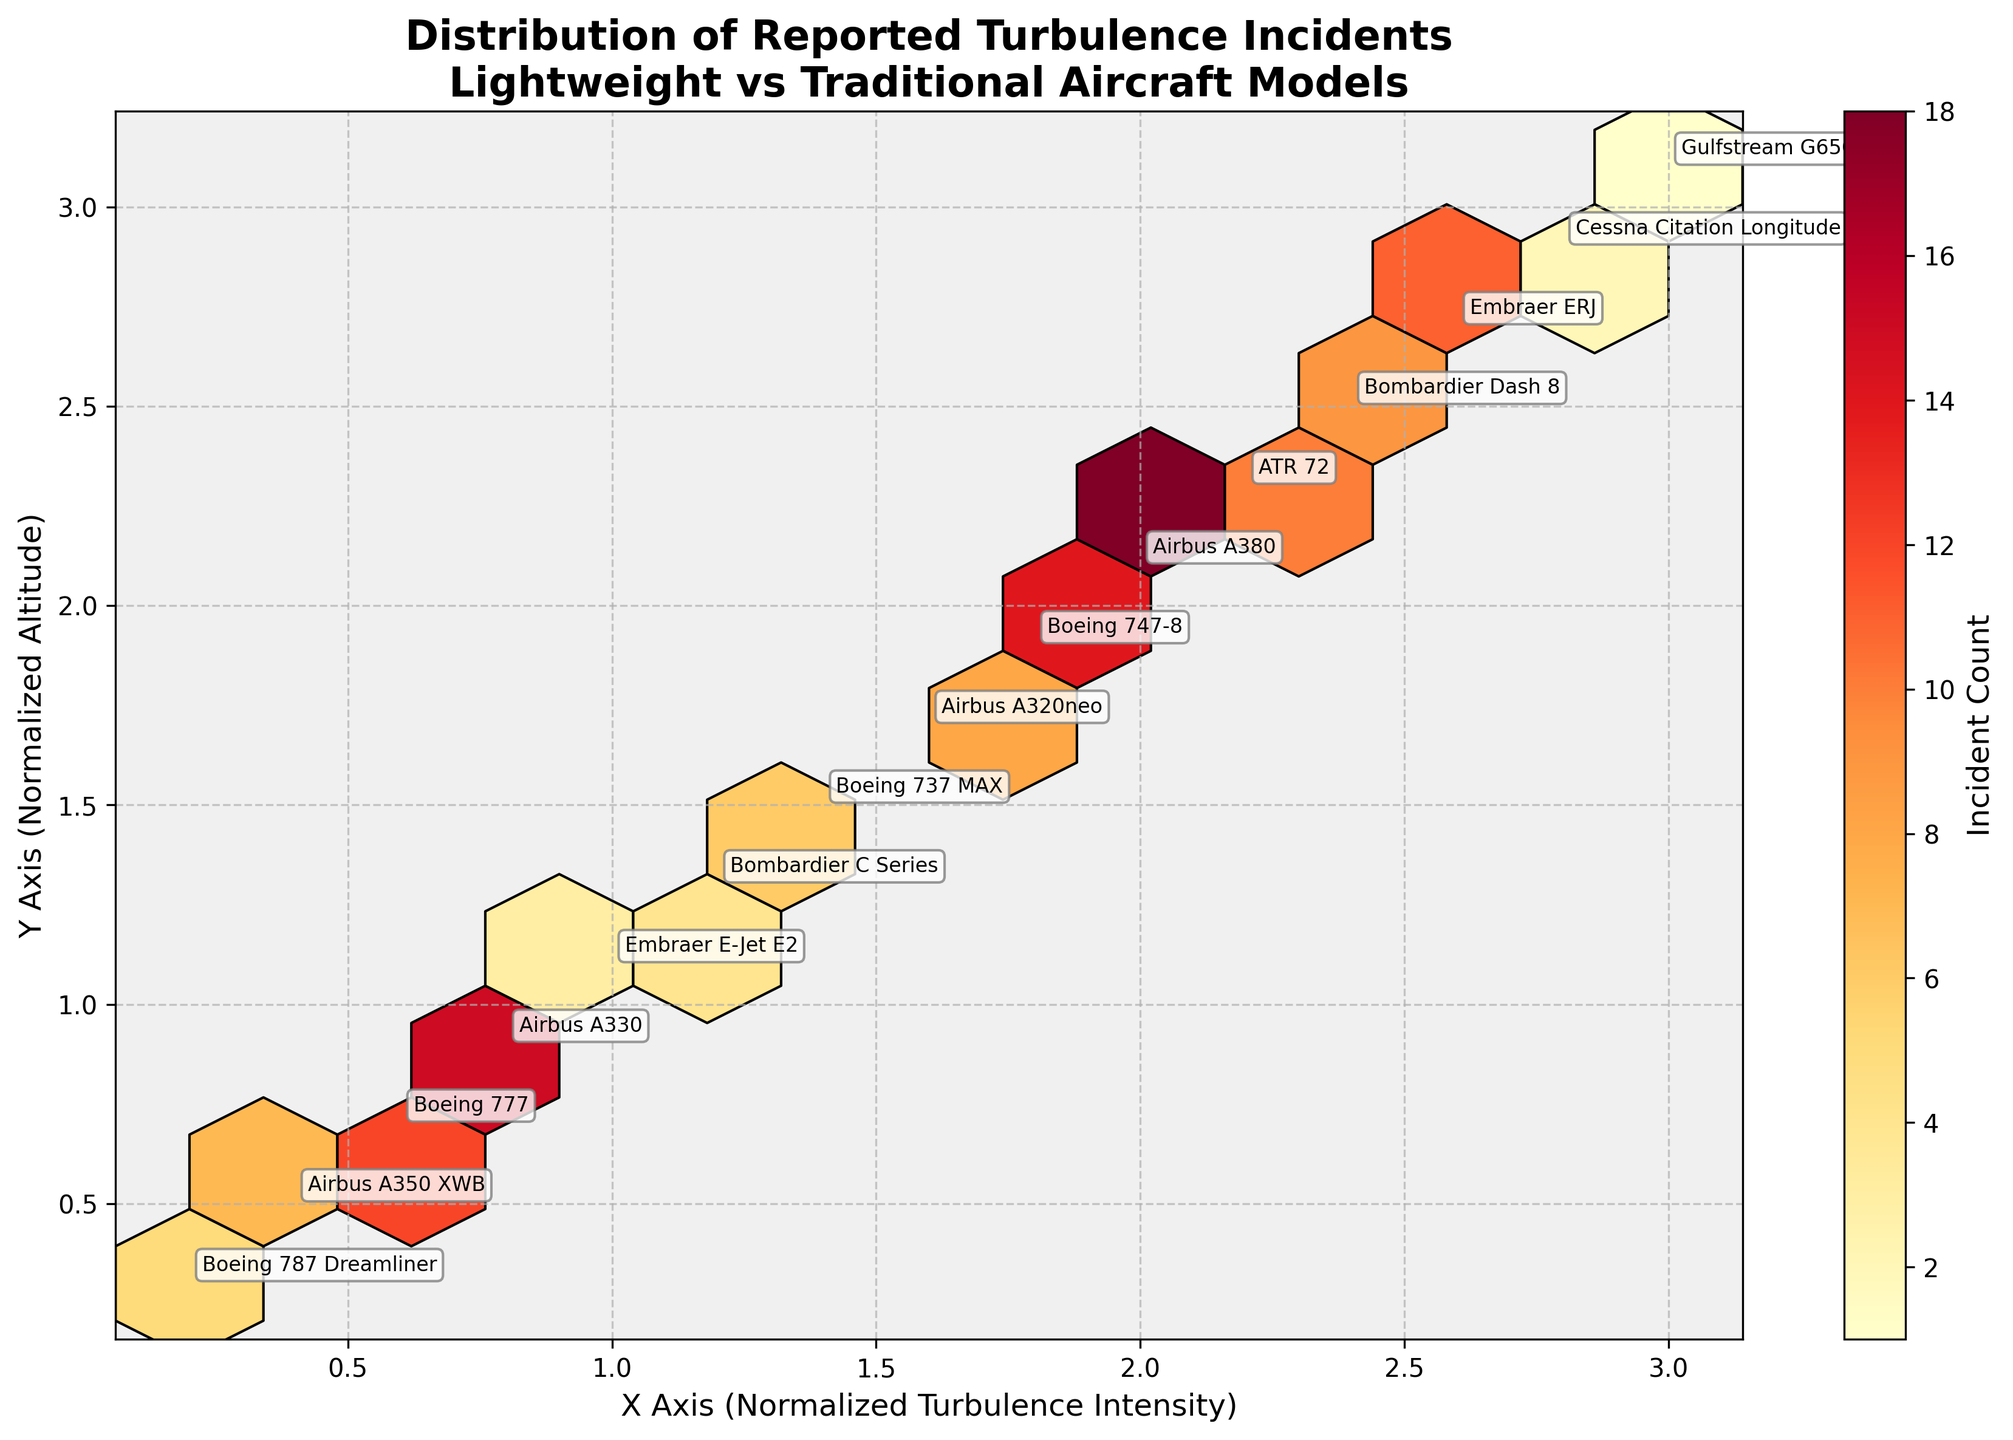What is the title of the figure? The title is located at the top of the figure in large, bold font. It reads "Distribution of Reported Turbulence Incidents\nLightweight vs Traditional Aircraft Models".
Answer: Distribution of Reported Turbulence Incidents\nLightweight vs Traditional Aircraft Models What are the labels for the X and Y axes? The X-axis and Y-axis labels are located at the bottom and left side of the plot, respectively. The X-axis is labeled "X Axis (Normalized Turbulence Intensity)" and the Y-axis is labeled "Y Axis (Normalized Altitude)".
Answer: X Axis (Normalized Turbulence Intensity) and Y Axis (Normalized Altitude) Which aircraft type has the highest incident count? By looking at the annotations near the hexagonal bins with the highest color intensity, we can see that the Airbus A380 has the most intense color, corresponding to the highest incident count.
Answer: Airbus A380 How many aircraft types are plotted in the figure? By counting the number of unique annotations in the figure, we can determine the total number of aircraft types represented in the plot.
Answer: 14 Is there a noticeable trend of turbulence incidents with respect to altitude? Observing the color gradient from top to bottom and left to right of the plot, it appears there are generally more intense colors (higher incident counts) as the altitude increases (higher Y-axis values).
Answer: Yes, turbulence incidents generally increase with altitude Which aircraft model is shown in the region with the lowest incident count? By identifying the least intense color (lightest color) marked with an annotation, we find it corresponds to the Gulfstream G650, located at approximately (3.0, 3.1).
Answer: Gulfstream G650 How do lightweight aircraft models compare to traditional models in terms of turbulence incident counts? Lightweight aircraft models like the Boeing 787 Dreamliner and Airbus A350 XWB generally show lower incident counts (lighter colors) compared to traditional models like the Airbus A330 and Airbus A380, which show higher incident counts (darker colors).
Answer: Lightweight models generally have lower incident counts Between the Boeing 787 Dreamliner and the Airbus A350 XWB, which one has more reported turbulence incidents? By comparing the color intensities and their corresponding annotations, the Airbus A350 XWB has a slightly more intense color, indicating a higher incident count than the Boeing 787 Dreamliner.
Answer: Airbus A350 XWB Calculate the average incident count for all plotted aircraft models. First, sum up all incident counts provided: 5+7+12+15+3+4+6+8+14+18+10+9+11+2+1 = 125. Then, divide by the number of aircraft types (14): 125 / 14 = approximately 8.93.
Answer: Approximately 8.93 Which aircraft type is found in the region with the coordinate (1.4, 1.5)? Locate the annotation near the specific coordinates (1.4, 1.5), revealing that the aircraft model is the Boeing 737 MAX.
Answer: Boeing 737 MAX 